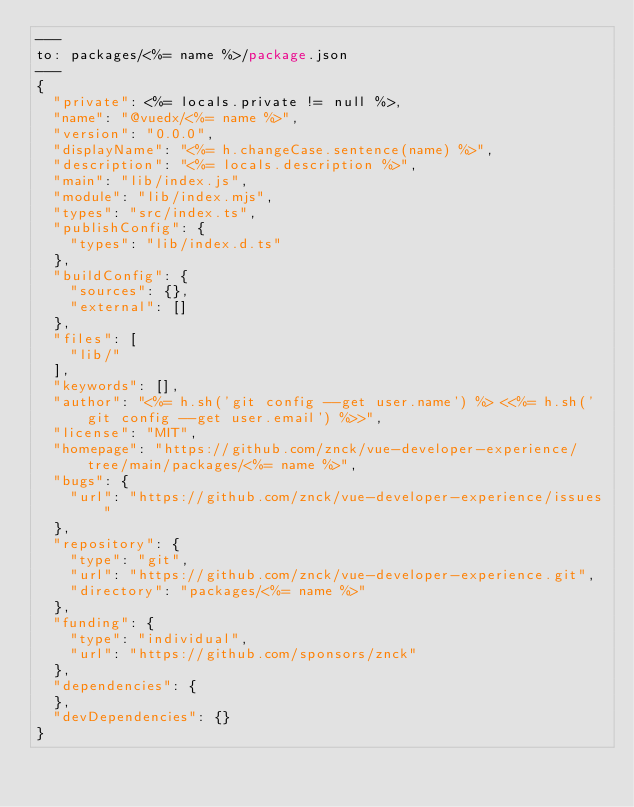Convert code to text. <code><loc_0><loc_0><loc_500><loc_500><_Perl_>---
to: packages/<%= name %>/package.json
---
{
  "private": <%= locals.private != null %>,
  "name": "@vuedx/<%= name %>",
  "version": "0.0.0",
  "displayName": "<%= h.changeCase.sentence(name) %>",
  "description": "<%= locals.description %>",
  "main": "lib/index.js",
  "module": "lib/index.mjs",
  "types": "src/index.ts",
  "publishConfig": {
    "types": "lib/index.d.ts"
  },
  "buildConfig": {
    "sources": {},
    "external": []
  },
  "files": [
    "lib/"
  ],
  "keywords": [],
  "author": "<%= h.sh('git config --get user.name') %> <<%= h.sh('git config --get user.email') %>>",
  "license": "MIT",
  "homepage": "https://github.com/znck/vue-developer-experience/tree/main/packages/<%= name %>",
  "bugs": {
    "url": "https://github.com/znck/vue-developer-experience/issues"
  },
  "repository": {
    "type": "git",
    "url": "https://github.com/znck/vue-developer-experience.git",
    "directory": "packages/<%= name %>"
  },
  "funding": {
    "type": "individual",
    "url": "https://github.com/sponsors/znck"
  },
  "dependencies": {
  },
  "devDependencies": {}
}
</code> 